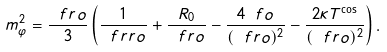<formula> <loc_0><loc_0><loc_500><loc_500>m _ { \varphi } ^ { 2 } = \frac { \ f r o } { 3 } \left ( \frac { 1 } { \ f r r o } + \frac { R _ { 0 } } { \ f r o } - \frac { 4 \ f o } { ( \ f r o ) ^ { 2 } } - \frac { 2 \kappa T ^ { \cos } } { ( \ f r o ) ^ { 2 } } \right ) .</formula> 